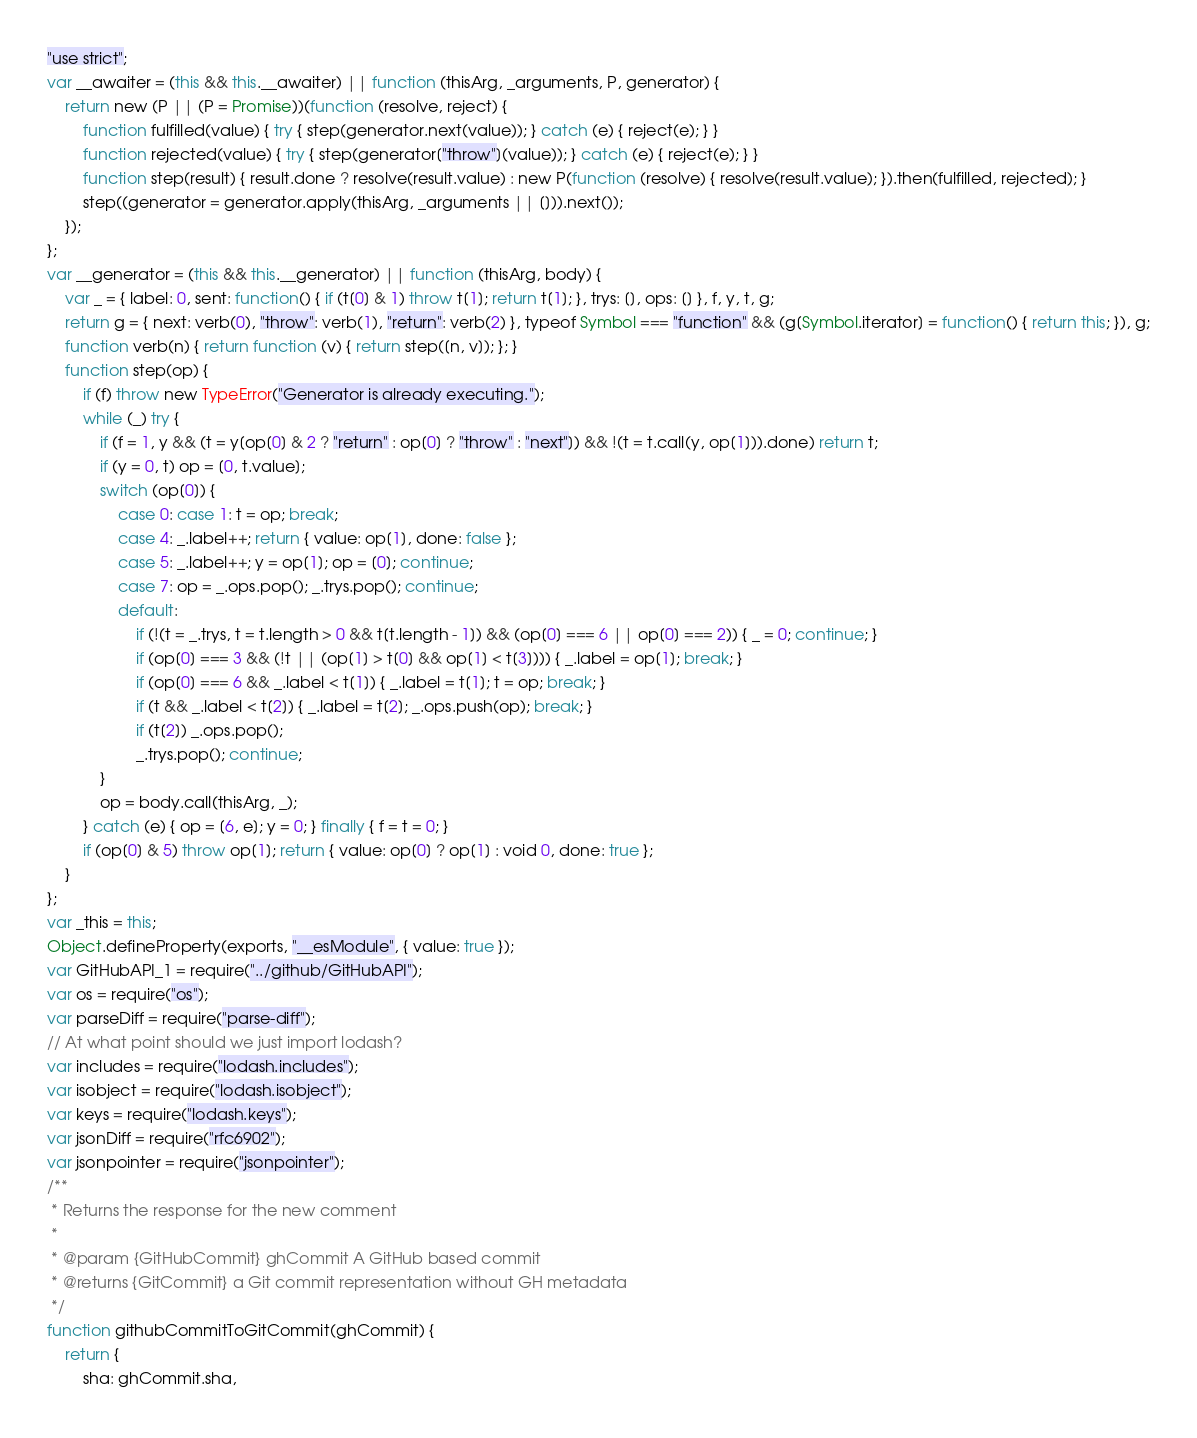Convert code to text. <code><loc_0><loc_0><loc_500><loc_500><_JavaScript_>"use strict";
var __awaiter = (this && this.__awaiter) || function (thisArg, _arguments, P, generator) {
    return new (P || (P = Promise))(function (resolve, reject) {
        function fulfilled(value) { try { step(generator.next(value)); } catch (e) { reject(e); } }
        function rejected(value) { try { step(generator["throw"](value)); } catch (e) { reject(e); } }
        function step(result) { result.done ? resolve(result.value) : new P(function (resolve) { resolve(result.value); }).then(fulfilled, rejected); }
        step((generator = generator.apply(thisArg, _arguments || [])).next());
    });
};
var __generator = (this && this.__generator) || function (thisArg, body) {
    var _ = { label: 0, sent: function() { if (t[0] & 1) throw t[1]; return t[1]; }, trys: [], ops: [] }, f, y, t, g;
    return g = { next: verb(0), "throw": verb(1), "return": verb(2) }, typeof Symbol === "function" && (g[Symbol.iterator] = function() { return this; }), g;
    function verb(n) { return function (v) { return step([n, v]); }; }
    function step(op) {
        if (f) throw new TypeError("Generator is already executing.");
        while (_) try {
            if (f = 1, y && (t = y[op[0] & 2 ? "return" : op[0] ? "throw" : "next"]) && !(t = t.call(y, op[1])).done) return t;
            if (y = 0, t) op = [0, t.value];
            switch (op[0]) {
                case 0: case 1: t = op; break;
                case 4: _.label++; return { value: op[1], done: false };
                case 5: _.label++; y = op[1]; op = [0]; continue;
                case 7: op = _.ops.pop(); _.trys.pop(); continue;
                default:
                    if (!(t = _.trys, t = t.length > 0 && t[t.length - 1]) && (op[0] === 6 || op[0] === 2)) { _ = 0; continue; }
                    if (op[0] === 3 && (!t || (op[1] > t[0] && op[1] < t[3]))) { _.label = op[1]; break; }
                    if (op[0] === 6 && _.label < t[1]) { _.label = t[1]; t = op; break; }
                    if (t && _.label < t[2]) { _.label = t[2]; _.ops.push(op); break; }
                    if (t[2]) _.ops.pop();
                    _.trys.pop(); continue;
            }
            op = body.call(thisArg, _);
        } catch (e) { op = [6, e]; y = 0; } finally { f = t = 0; }
        if (op[0] & 5) throw op[1]; return { value: op[0] ? op[1] : void 0, done: true };
    }
};
var _this = this;
Object.defineProperty(exports, "__esModule", { value: true });
var GitHubAPI_1 = require("../github/GitHubAPI");
var os = require("os");
var parseDiff = require("parse-diff");
// At what point should we just import lodash?
var includes = require("lodash.includes");
var isobject = require("lodash.isobject");
var keys = require("lodash.keys");
var jsonDiff = require("rfc6902");
var jsonpointer = require("jsonpointer");
/**
 * Returns the response for the new comment
 *
 * @param {GitHubCommit} ghCommit A GitHub based commit
 * @returns {GitCommit} a Git commit representation without GH metadata
 */
function githubCommitToGitCommit(ghCommit) {
    return {
        sha: ghCommit.sha,</code> 